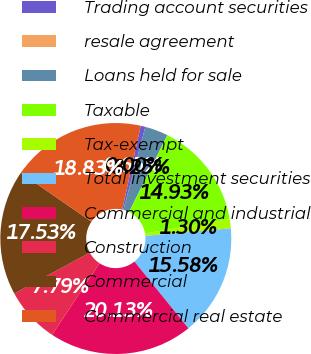Convert chart to OTSL. <chart><loc_0><loc_0><loc_500><loc_500><pie_chart><fcel>Trading account securities<fcel>resale agreement<fcel>Loans held for sale<fcel>Taxable<fcel>Tax-exempt<fcel>Total investment securities<fcel>Commercial and industrial<fcel>Construction<fcel>Commercial<fcel>Commercial real estate<nl><fcel>0.65%<fcel>0.0%<fcel>3.25%<fcel>14.93%<fcel>1.3%<fcel>15.58%<fcel>20.13%<fcel>7.79%<fcel>17.53%<fcel>18.83%<nl></chart> 